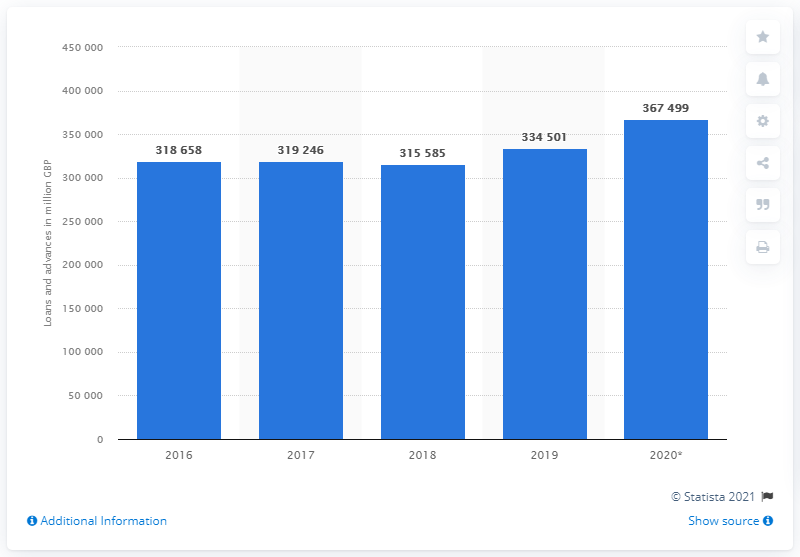Mention a couple of crucial points in this snapshot. The total loan value in 2020 was 367,499. 